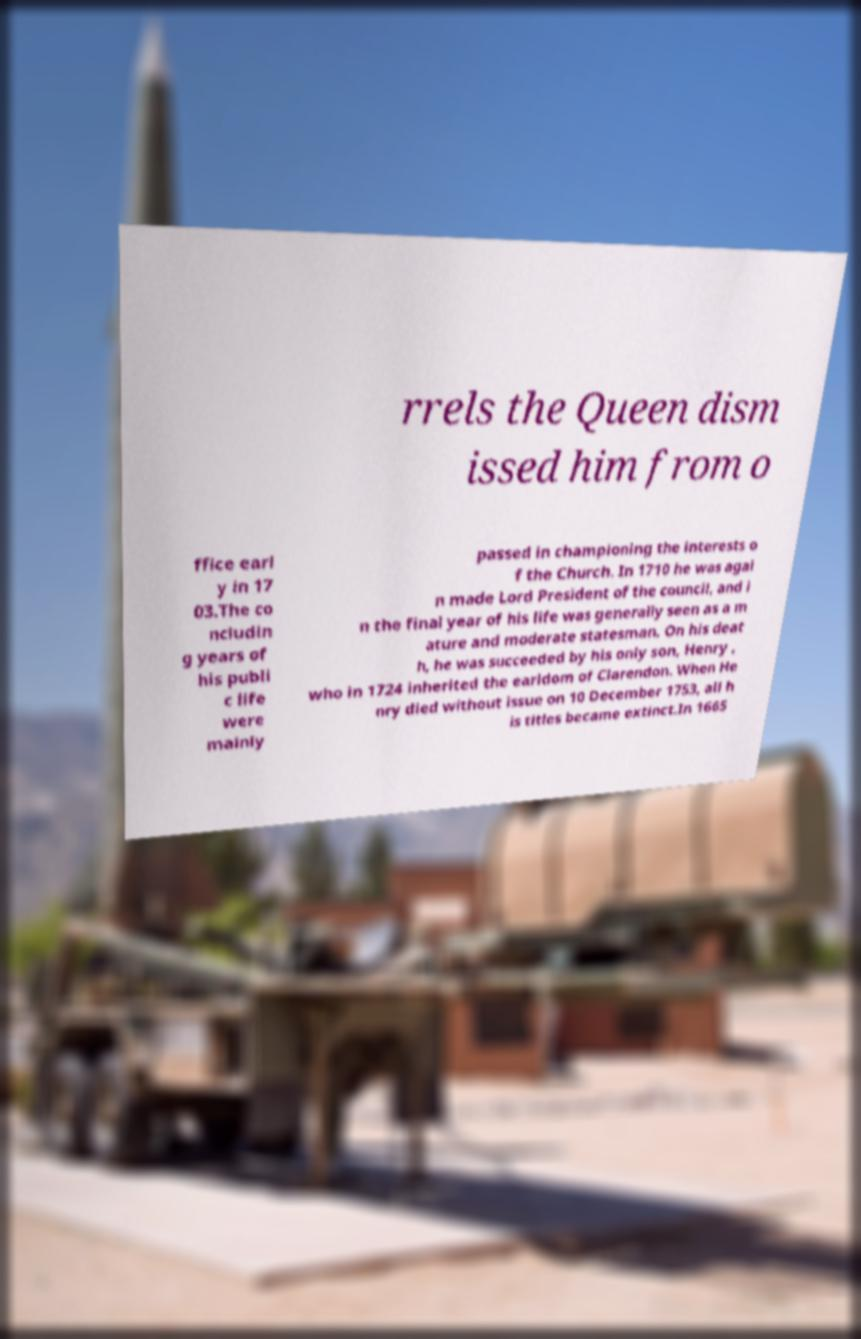I need the written content from this picture converted into text. Can you do that? rrels the Queen dism issed him from o ffice earl y in 17 03.The co ncludin g years of his publi c life were mainly passed in championing the interests o f the Church. In 1710 he was agai n made Lord President of the council, and i n the final year of his life was generally seen as a m ature and moderate statesman. On his deat h, he was succeeded by his only son, Henry , who in 1724 inherited the earldom of Clarendon. When He nry died without issue on 10 December 1753, all h is titles became extinct.In 1665 